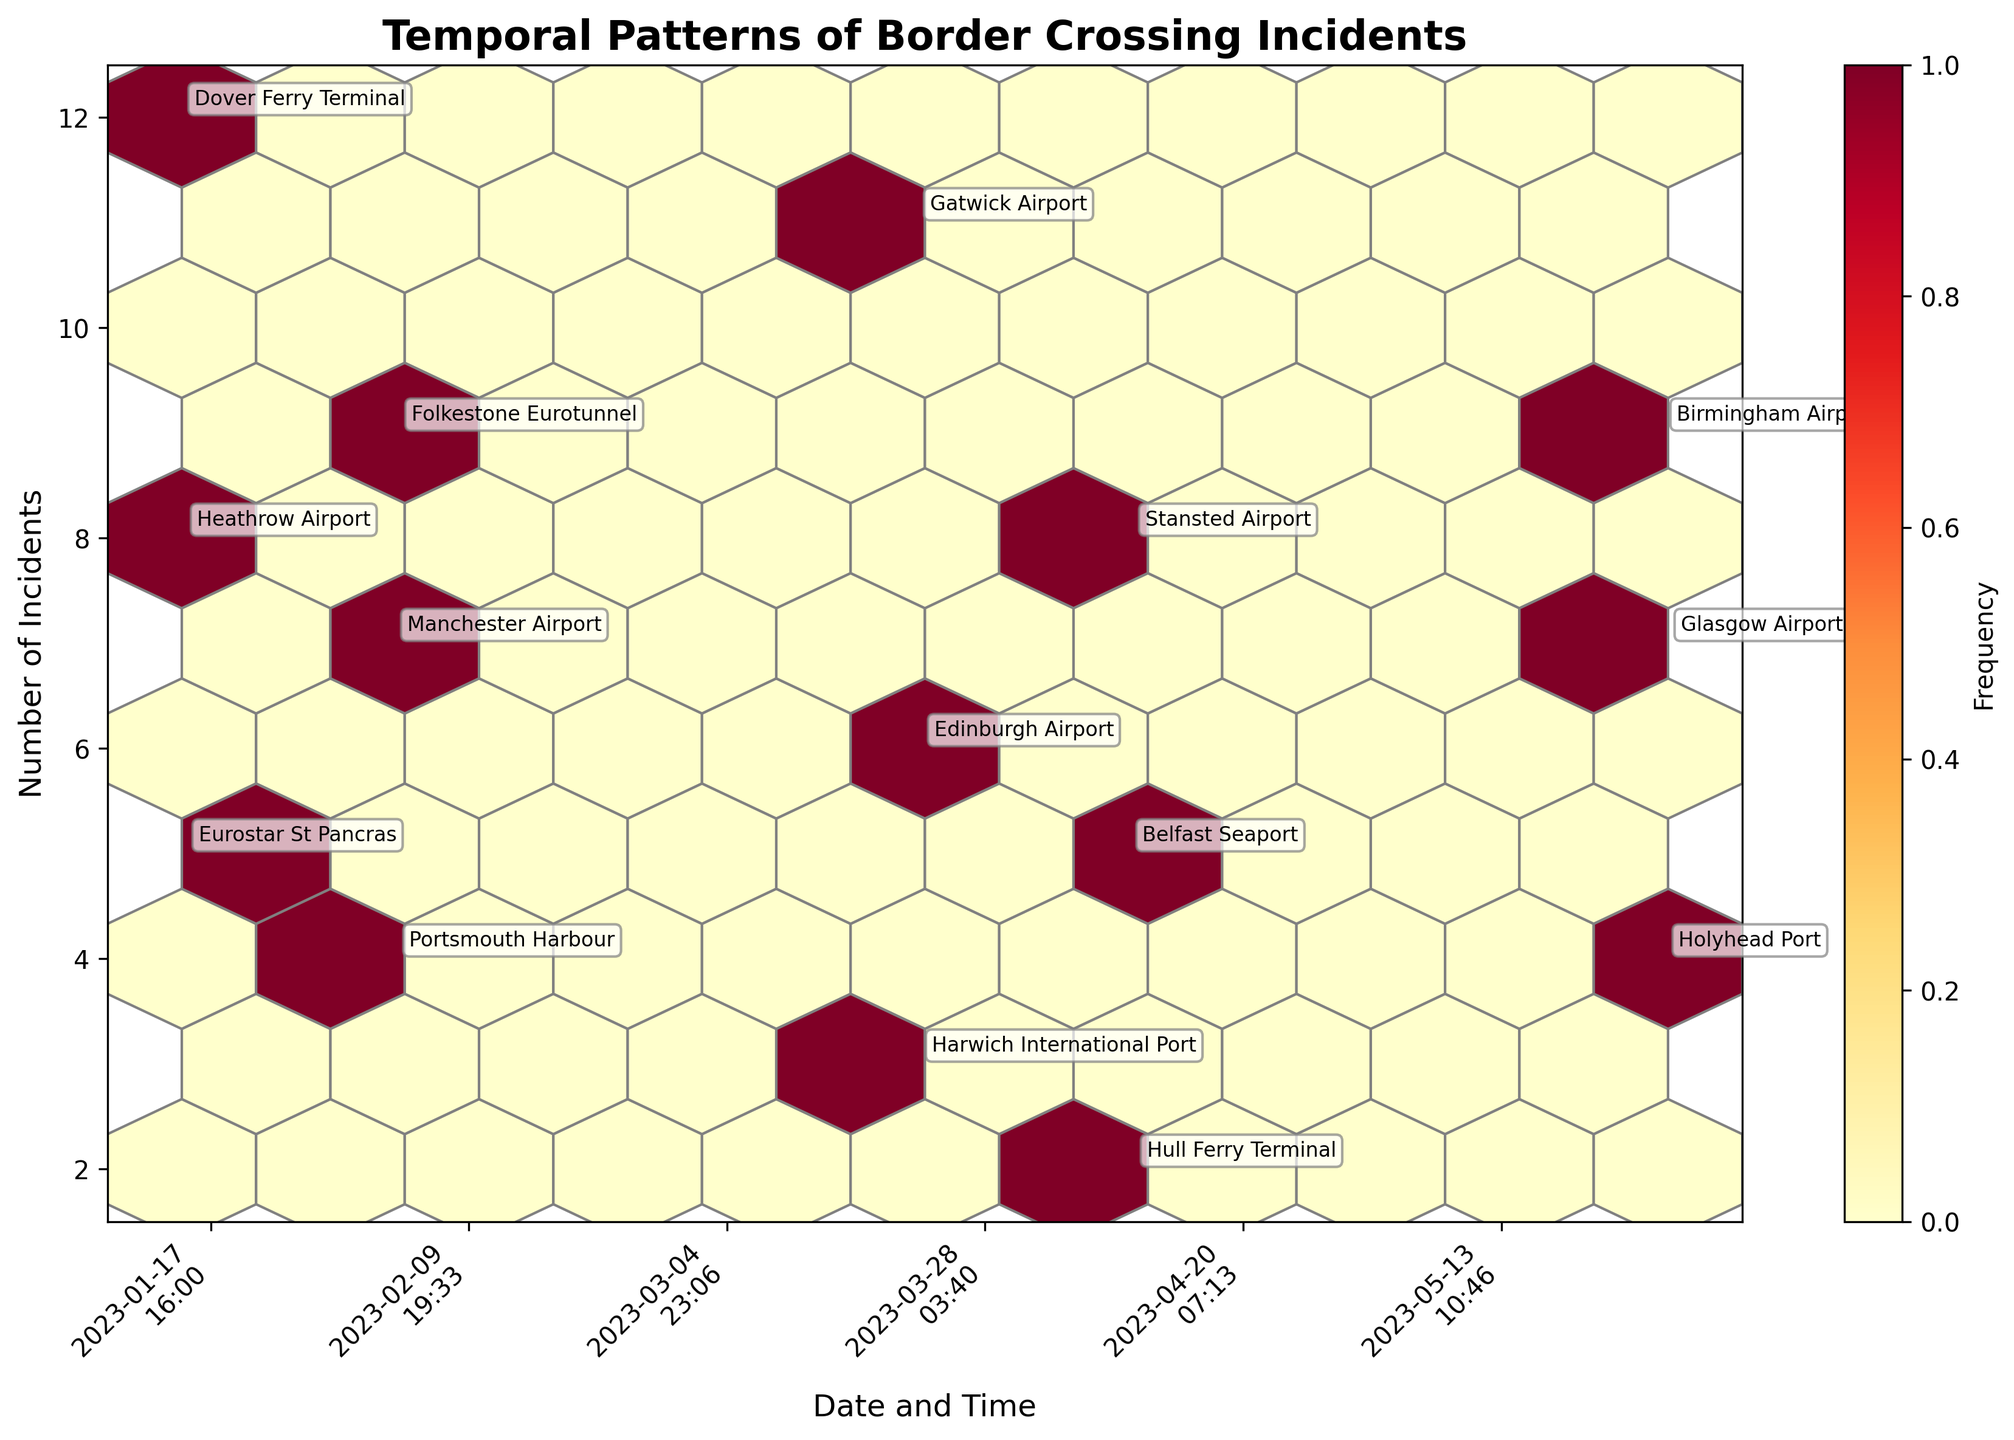How many total incidents are depicted on the plot? To find this, we sum all the incidents from the provided data: 12 + 8 + 5 + 7 + 4 + 9 + 11 + 3 + 6 + 5 + 8 + 2 + 9 + 4 + 7 = 100
Answer: 100 What does the color intensity in the hexagons represent? The color intensity represents the frequency of incidents occurring within the same date-time and incident range. Darker shades typically indicate higher frequencies.
Answer: Frequency of incidents Which date-time had the highest number of incidents and what was the entry point? By looking at the annotations on the hexbin plot, the date-time with the highest number of incidents is 2023-01-15 09:30 at Dover Ferry Terminal with 12 incidents.
Answer: 2023-01-15 09:30 at Dover Ferry Terminal How many entry points experienced more than 7 incidents? Referencing the annotations on the plot: Dover Ferry Terminal (12), Heathrow Airport (8), Gatwick Airport (11), Stansted Airport (8), Birmingham Airport (9), Folkestone Eurotunnel (9), Glasgow Airport (7), Manchester Airport (7). We count these entry points to find the total number.
Answer: 7 What is the range of incidents captured in the plot and which colors on the plot represent the lowest and highest frequencies? The range of incidents is from 2 to 12. The color representing the lowest frequency (2) is lighter shades, while the highest frequency (12) is denoted by darker shades on the hexbin plot.
Answer: 2 to 12; lighter to darker shades Do incidents concentrate more at specific times of the day, and if so when? Inspecting the distribution pattern along the x-axis corresponding to specific times, incidents appear more concentrated in the morning (07:50-11:15) and late afternoon (15:55-20:30).
Answer: Morning and late afternoon Which month depicted the highest frequency of border crossing incidents? Aggregating incidents by month from the data, March has 20 incidents (11 + 3 + 6), which is higher compared to the other months.
Answer: March How does the frequency of incidents at airports compare with seaports and rail terminals? Summing up incidents at airports (Heathrow, Manchester, Gatwick, Edinburgh, Stansted, Birmingham, Glasgow) and comparing it with summing incidents at seaports and rail terminals (Dover, Portsmouth, Harwich, Belfast, Hull, Holyhead, Folkestone, Eurostar): Airports (8 + 7 + 11 + 6 + 8 + 9 + 7 = 56) and Non-Airports (12 + 4 + 3 + 5 + 2 + 4 + 9 + 5 = 44).
Answer: Higher for airports 